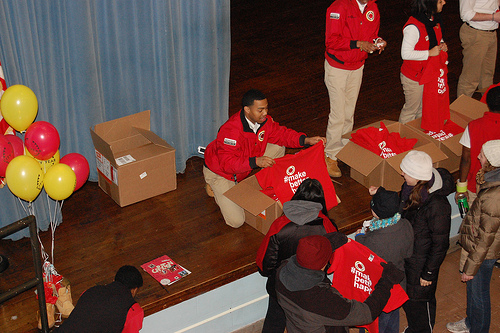<image>
Is the balloon next to the white hat? No. The balloon is not positioned next to the white hat. They are located in different areas of the scene. 